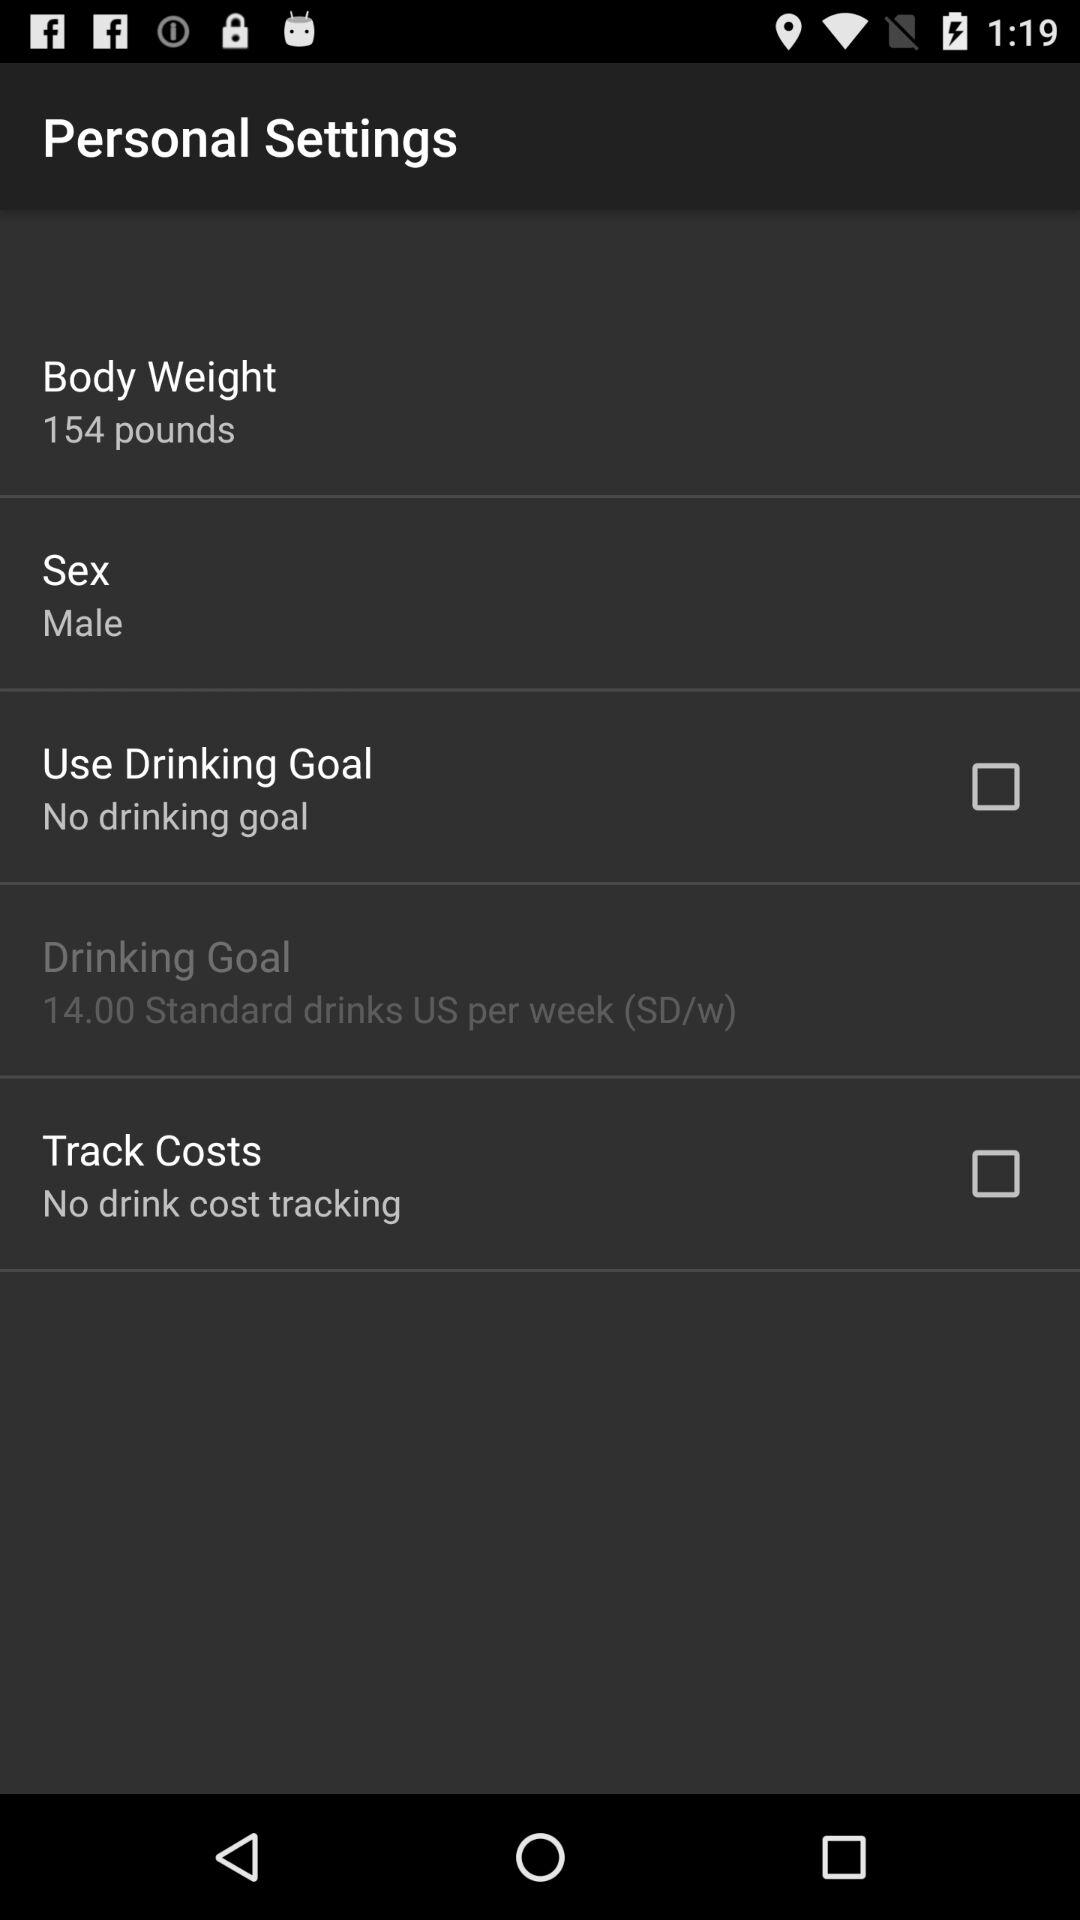What is the status of the use drinking goal? The status is off. 